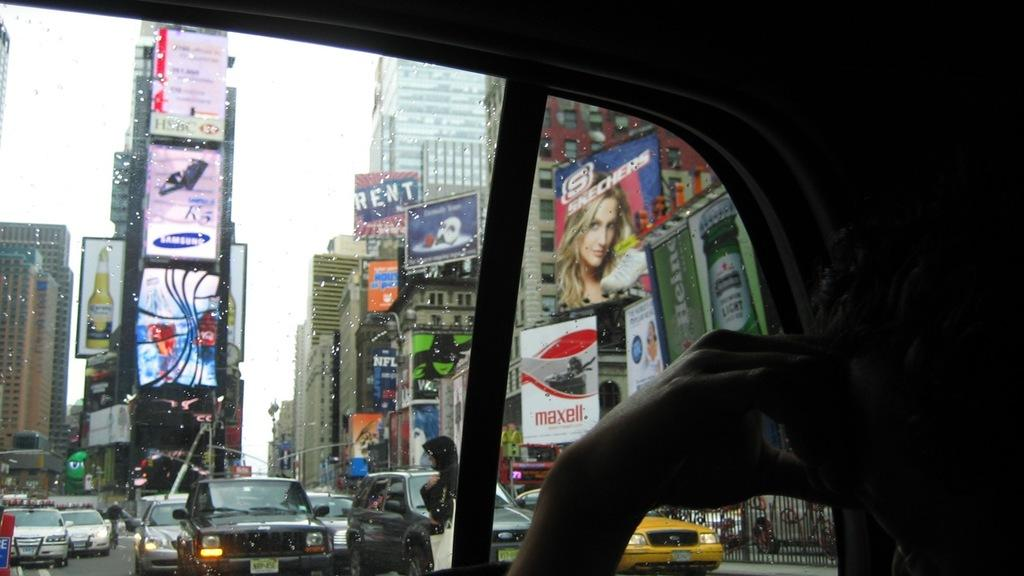<image>
Describe the image concisely. Ads for Maxell, Corona, and Skechers cover many NYC buildings. 